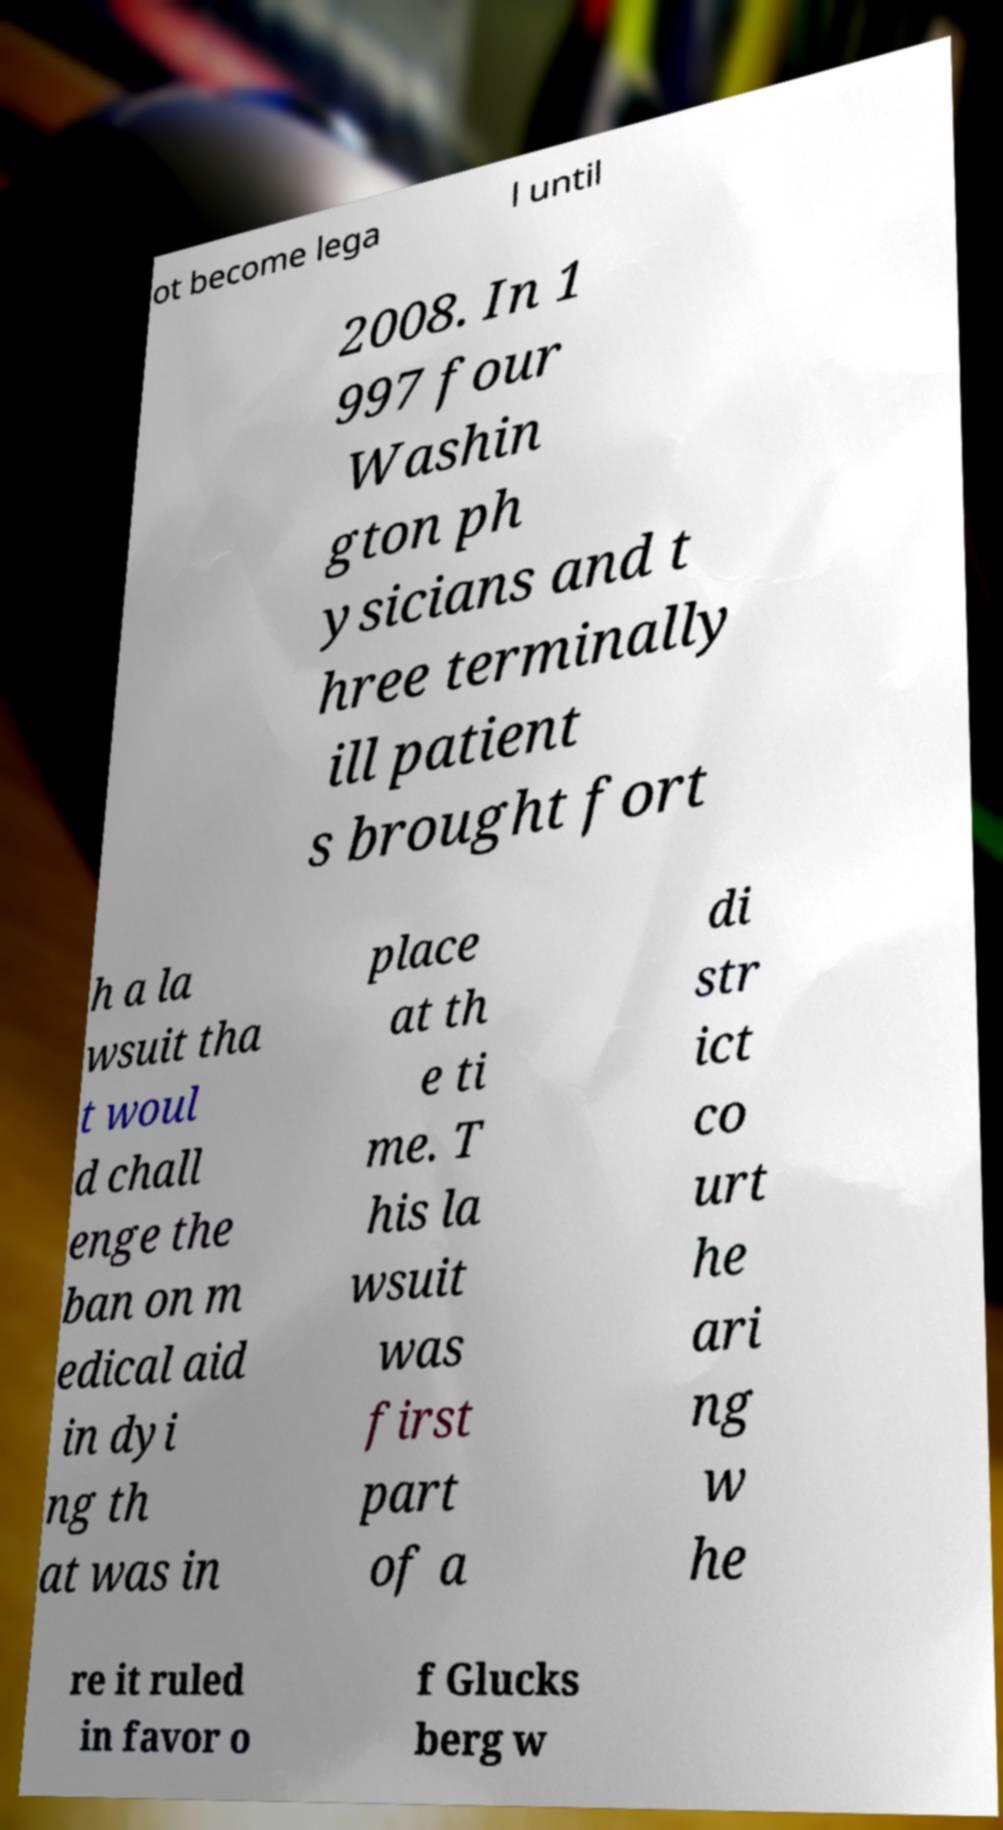For documentation purposes, I need the text within this image transcribed. Could you provide that? ot become lega l until 2008. In 1 997 four Washin gton ph ysicians and t hree terminally ill patient s brought fort h a la wsuit tha t woul d chall enge the ban on m edical aid in dyi ng th at was in place at th e ti me. T his la wsuit was first part of a di str ict co urt he ari ng w he re it ruled in favor o f Glucks berg w 